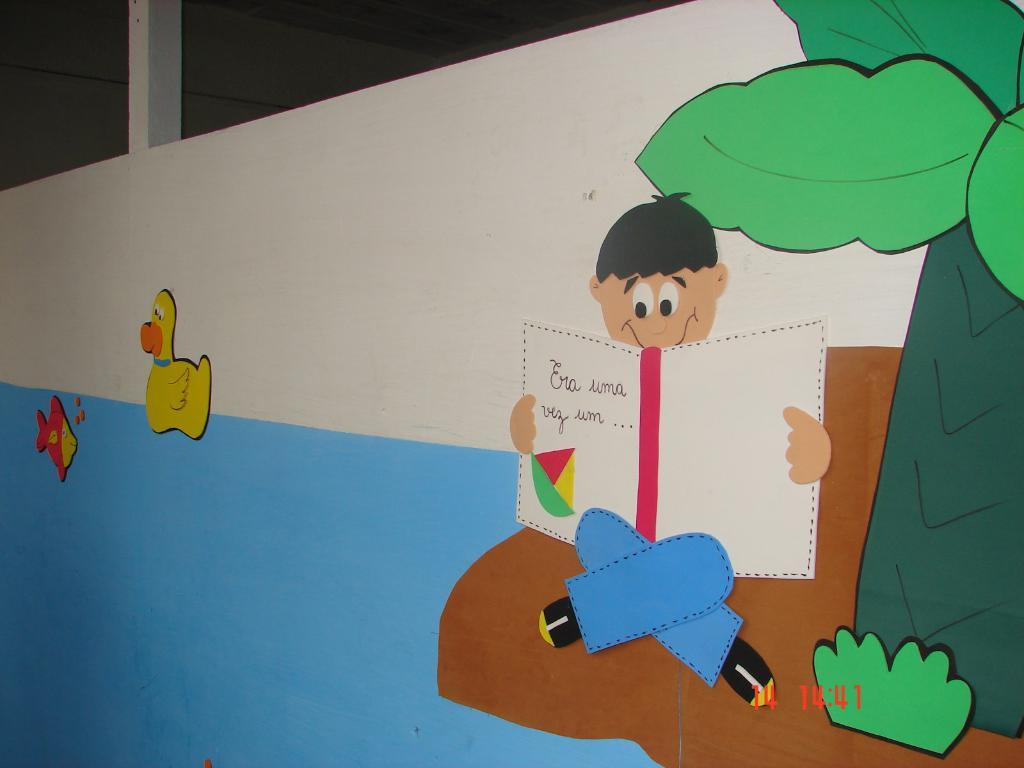What is present on the wall in the image? There is a painting on the wall in the image. What subjects are included in the painting? The painting includes a duck, a fish, a tree, and a boy holding a book. Can you describe the boy in the painting? The boy in the painting is holding a book. Is there a servant in the painting, attending to the boy? There is no servant present in the painting; it only includes the boy holding a book. 